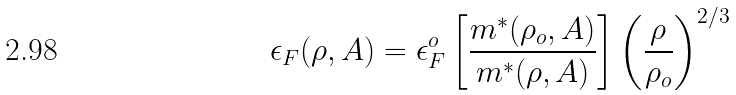Convert formula to latex. <formula><loc_0><loc_0><loc_500><loc_500>\epsilon _ { F } ( \rho , A ) = \epsilon _ { F } ^ { o } \left [ \frac { m ^ { * } ( \rho _ { o } , A ) } { m ^ { * } ( \rho , A ) } \right ] \left ( \frac { \rho } { \rho _ { o } } \right ) ^ { 2 / 3 }</formula> 